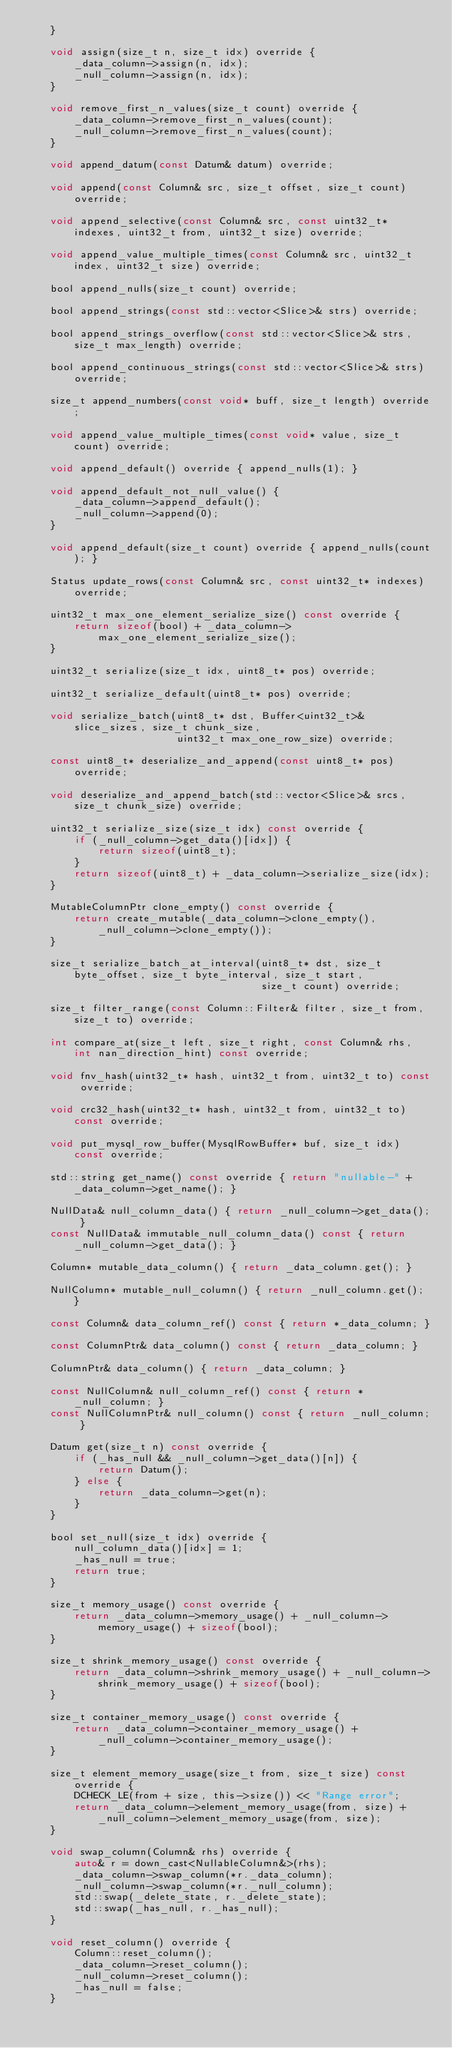<code> <loc_0><loc_0><loc_500><loc_500><_C_>    }

    void assign(size_t n, size_t idx) override {
        _data_column->assign(n, idx);
        _null_column->assign(n, idx);
    }

    void remove_first_n_values(size_t count) override {
        _data_column->remove_first_n_values(count);
        _null_column->remove_first_n_values(count);
    }

    void append_datum(const Datum& datum) override;

    void append(const Column& src, size_t offset, size_t count) override;

    void append_selective(const Column& src, const uint32_t* indexes, uint32_t from, uint32_t size) override;

    void append_value_multiple_times(const Column& src, uint32_t index, uint32_t size) override;

    bool append_nulls(size_t count) override;

    bool append_strings(const std::vector<Slice>& strs) override;

    bool append_strings_overflow(const std::vector<Slice>& strs, size_t max_length) override;

    bool append_continuous_strings(const std::vector<Slice>& strs) override;

    size_t append_numbers(const void* buff, size_t length) override;

    void append_value_multiple_times(const void* value, size_t count) override;

    void append_default() override { append_nulls(1); }

    void append_default_not_null_value() {
        _data_column->append_default();
        _null_column->append(0);
    }

    void append_default(size_t count) override { append_nulls(count); }

    Status update_rows(const Column& src, const uint32_t* indexes) override;

    uint32_t max_one_element_serialize_size() const override {
        return sizeof(bool) + _data_column->max_one_element_serialize_size();
    }

    uint32_t serialize(size_t idx, uint8_t* pos) override;

    uint32_t serialize_default(uint8_t* pos) override;

    void serialize_batch(uint8_t* dst, Buffer<uint32_t>& slice_sizes, size_t chunk_size,
                         uint32_t max_one_row_size) override;

    const uint8_t* deserialize_and_append(const uint8_t* pos) override;

    void deserialize_and_append_batch(std::vector<Slice>& srcs, size_t chunk_size) override;

    uint32_t serialize_size(size_t idx) const override {
        if (_null_column->get_data()[idx]) {
            return sizeof(uint8_t);
        }
        return sizeof(uint8_t) + _data_column->serialize_size(idx);
    }

    MutableColumnPtr clone_empty() const override {
        return create_mutable(_data_column->clone_empty(), _null_column->clone_empty());
    }

    size_t serialize_batch_at_interval(uint8_t* dst, size_t byte_offset, size_t byte_interval, size_t start,
                                       size_t count) override;

    size_t filter_range(const Column::Filter& filter, size_t from, size_t to) override;

    int compare_at(size_t left, size_t right, const Column& rhs, int nan_direction_hint) const override;

    void fnv_hash(uint32_t* hash, uint32_t from, uint32_t to) const override;

    void crc32_hash(uint32_t* hash, uint32_t from, uint32_t to) const override;

    void put_mysql_row_buffer(MysqlRowBuffer* buf, size_t idx) const override;

    std::string get_name() const override { return "nullable-" + _data_column->get_name(); }

    NullData& null_column_data() { return _null_column->get_data(); }
    const NullData& immutable_null_column_data() const { return _null_column->get_data(); }

    Column* mutable_data_column() { return _data_column.get(); }

    NullColumn* mutable_null_column() { return _null_column.get(); }

    const Column& data_column_ref() const { return *_data_column; }

    const ColumnPtr& data_column() const { return _data_column; }

    ColumnPtr& data_column() { return _data_column; }

    const NullColumn& null_column_ref() const { return *_null_column; }
    const NullColumnPtr& null_column() const { return _null_column; }

    Datum get(size_t n) const override {
        if (_has_null && _null_column->get_data()[n]) {
            return Datum();
        } else {
            return _data_column->get(n);
        }
    }

    bool set_null(size_t idx) override {
        null_column_data()[idx] = 1;
        _has_null = true;
        return true;
    }

    size_t memory_usage() const override {
        return _data_column->memory_usage() + _null_column->memory_usage() + sizeof(bool);
    }

    size_t shrink_memory_usage() const override {
        return _data_column->shrink_memory_usage() + _null_column->shrink_memory_usage() + sizeof(bool);
    }

    size_t container_memory_usage() const override {
        return _data_column->container_memory_usage() + _null_column->container_memory_usage();
    }

    size_t element_memory_usage(size_t from, size_t size) const override {
        DCHECK_LE(from + size, this->size()) << "Range error";
        return _data_column->element_memory_usage(from, size) + _null_column->element_memory_usage(from, size);
    }

    void swap_column(Column& rhs) override {
        auto& r = down_cast<NullableColumn&>(rhs);
        _data_column->swap_column(*r._data_column);
        _null_column->swap_column(*r._null_column);
        std::swap(_delete_state, r._delete_state);
        std::swap(_has_null, r._has_null);
    }

    void reset_column() override {
        Column::reset_column();
        _data_column->reset_column();
        _null_column->reset_column();
        _has_null = false;
    }
</code> 